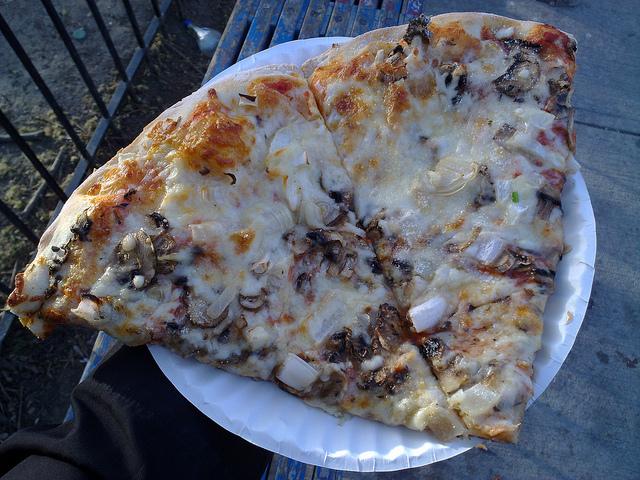Is there any sausage on the pizza?
Short answer required. No. How many slices are there?
Concise answer only. 2. Is this inside?
Short answer required. No. 